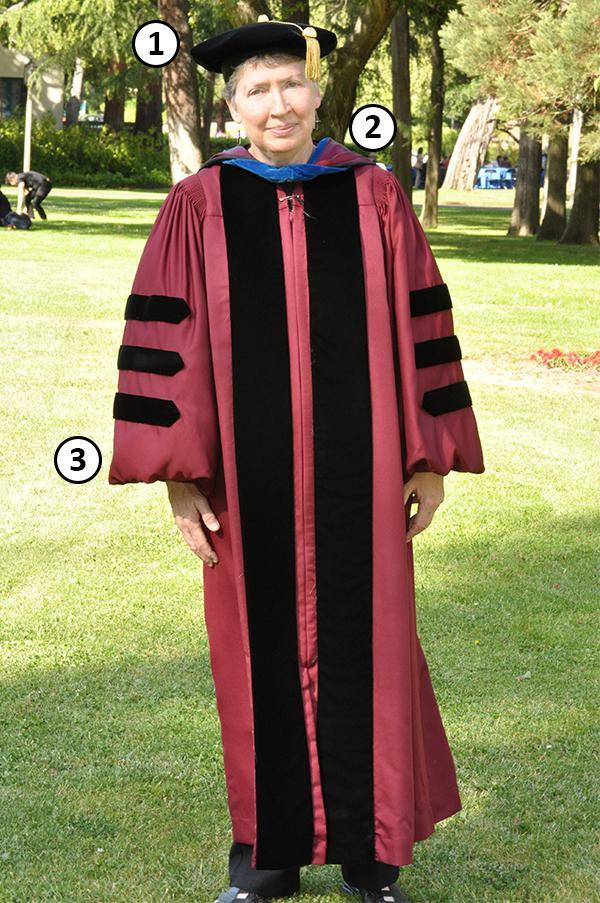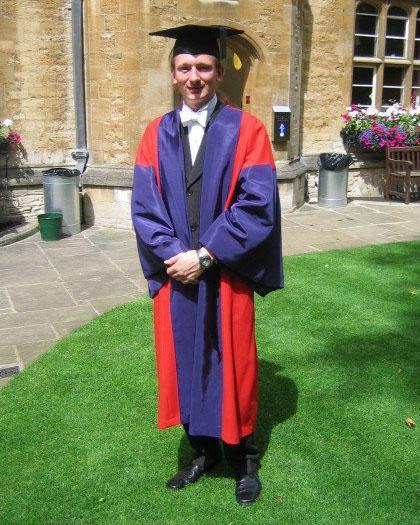The first image is the image on the left, the second image is the image on the right. For the images shown, is this caption "Right image shows one male graduate posed in colorful gown on grass." true? Answer yes or no. Yes. The first image is the image on the left, the second image is the image on the right. Considering the images on both sides, is "There are no more than 3 graduates pictured." valid? Answer yes or no. Yes. 